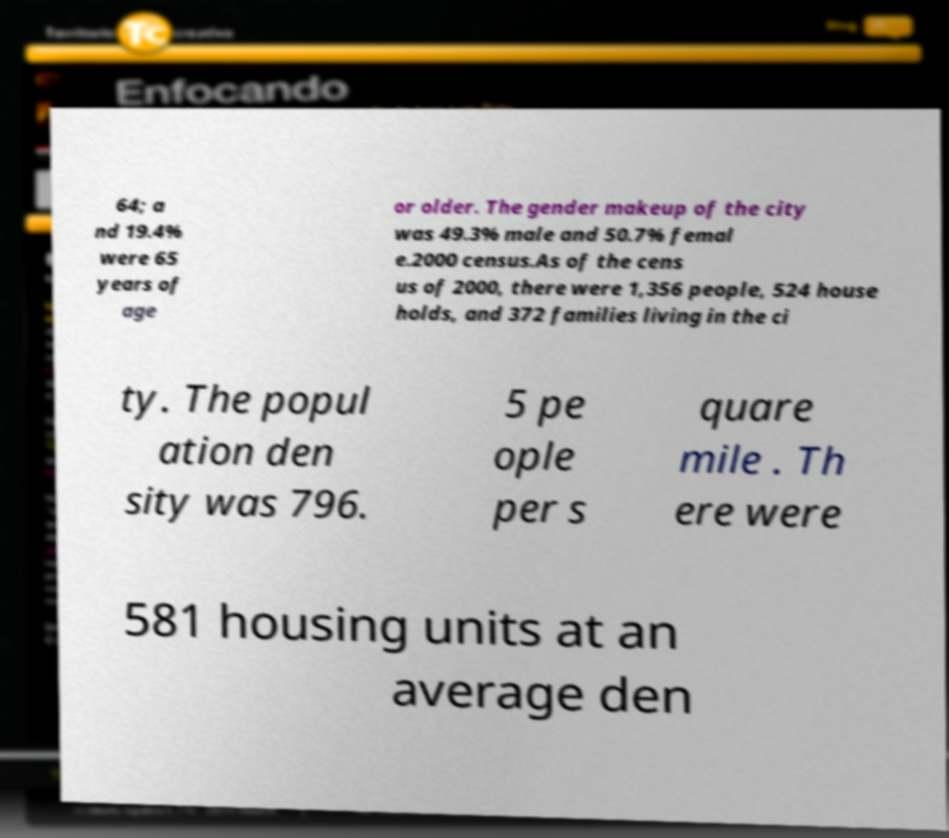I need the written content from this picture converted into text. Can you do that? 64; a nd 19.4% were 65 years of age or older. The gender makeup of the city was 49.3% male and 50.7% femal e.2000 census.As of the cens us of 2000, there were 1,356 people, 524 house holds, and 372 families living in the ci ty. The popul ation den sity was 796. 5 pe ople per s quare mile . Th ere were 581 housing units at an average den 